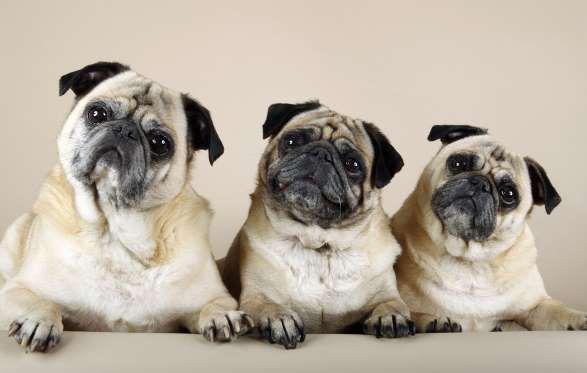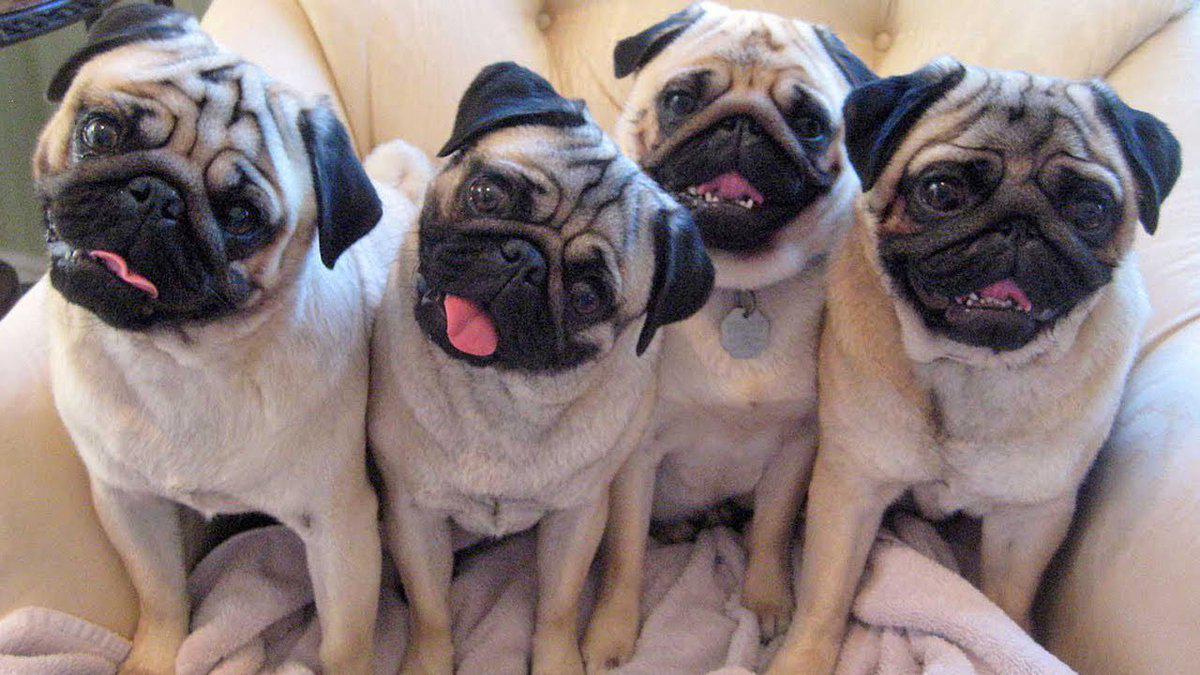The first image is the image on the left, the second image is the image on the right. Evaluate the accuracy of this statement regarding the images: "At least one of the dogs is near a human.". Is it true? Answer yes or no. No. 